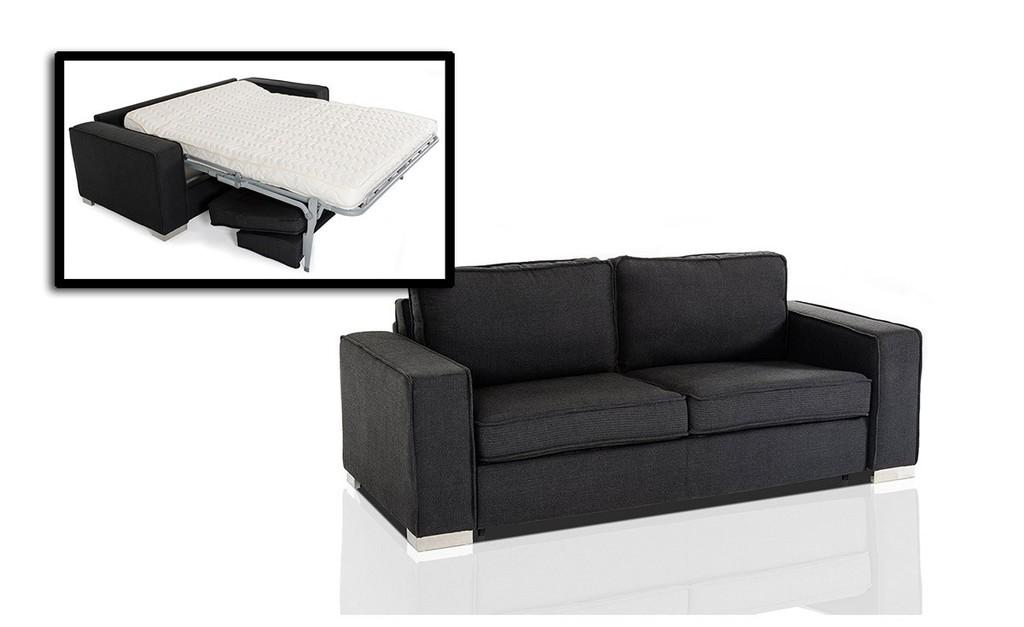What type of furniture is in the image? There is a black color sofa in the image. What else can be seen in the image besides the sofa? There is a screen in the image. What is displayed on the screen? The screen displays a sofa and a bed. What is the color of the sofa and bed on the screen? The sofa and bed on the screen are white in color. What type of cabbage is sitting on the white sofa in the image? There is no cabbage present in the image. How many light sources are visible in the image? The image does not provide information about light sources, so it cannot be determined from the image. 